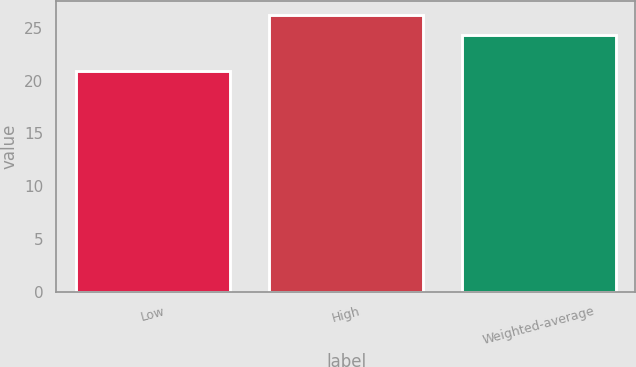Convert chart. <chart><loc_0><loc_0><loc_500><loc_500><bar_chart><fcel>Low<fcel>High<fcel>Weighted-average<nl><fcel>20.9<fcel>26.2<fcel>24.3<nl></chart> 